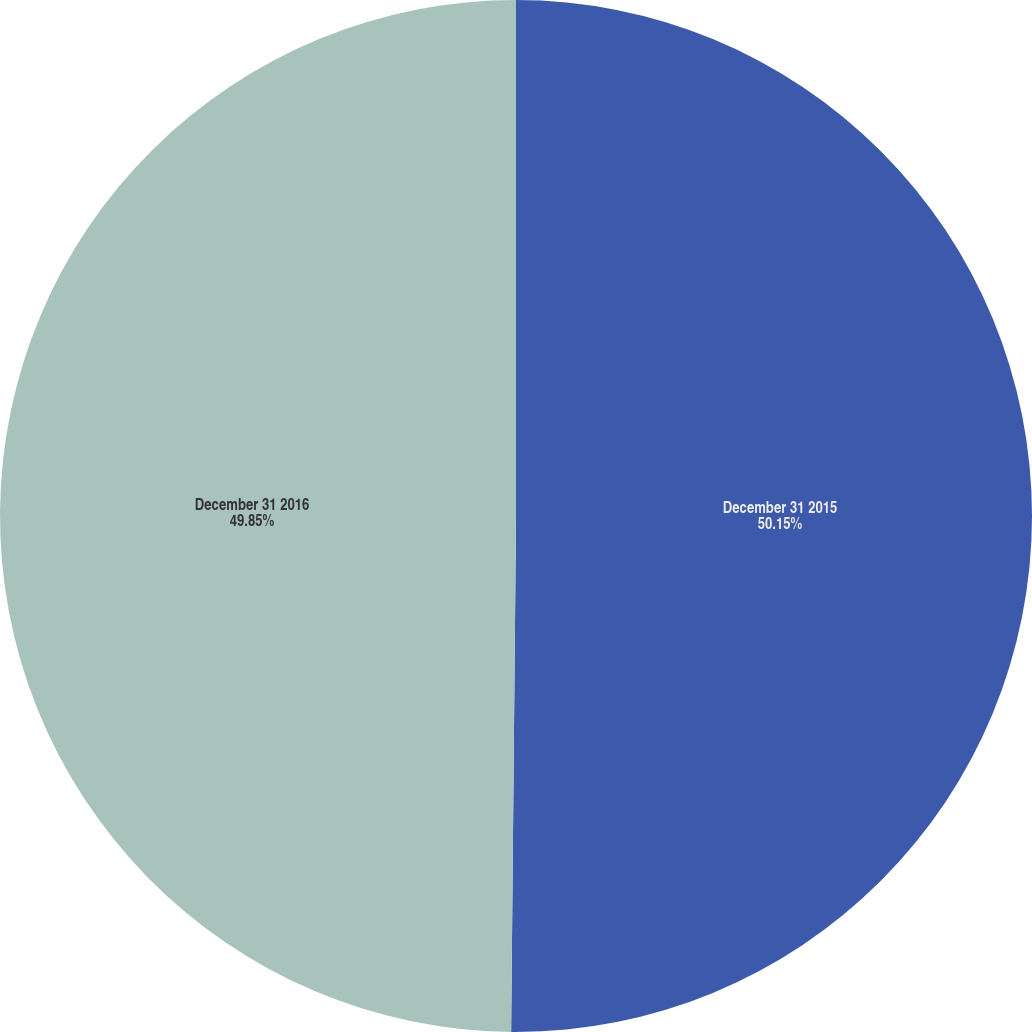Convert chart to OTSL. <chart><loc_0><loc_0><loc_500><loc_500><pie_chart><fcel>December 31 2015<fcel>December 31 2016<nl><fcel>50.15%<fcel>49.85%<nl></chart> 